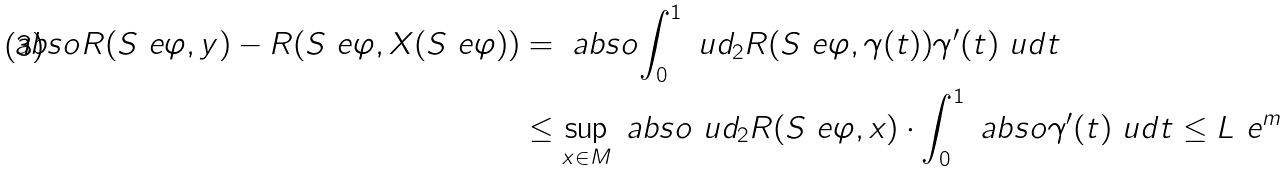<formula> <loc_0><loc_0><loc_500><loc_500>\ a b s o { R ( S _ { \ } e \varphi , y ) - R ( S _ { \ } e \varphi , X ( S _ { \ } e \varphi ) ) } & = \ a b s o { \int _ { 0 } ^ { 1 } \ u d _ { 2 } R ( S _ { \ } e \varphi , \gamma ( t ) ) \gamma ^ { \prime } ( t ) \ u d t } \\ & \leq \sup _ { x \in M } \ a b s o { \ u d _ { 2 } R ( S _ { \ } e \varphi , x ) } \cdot \int _ { 0 } ^ { 1 } \ a b s o { \gamma ^ { \prime } ( t ) } \ u d t \leq L \ e ^ { m }</formula> 